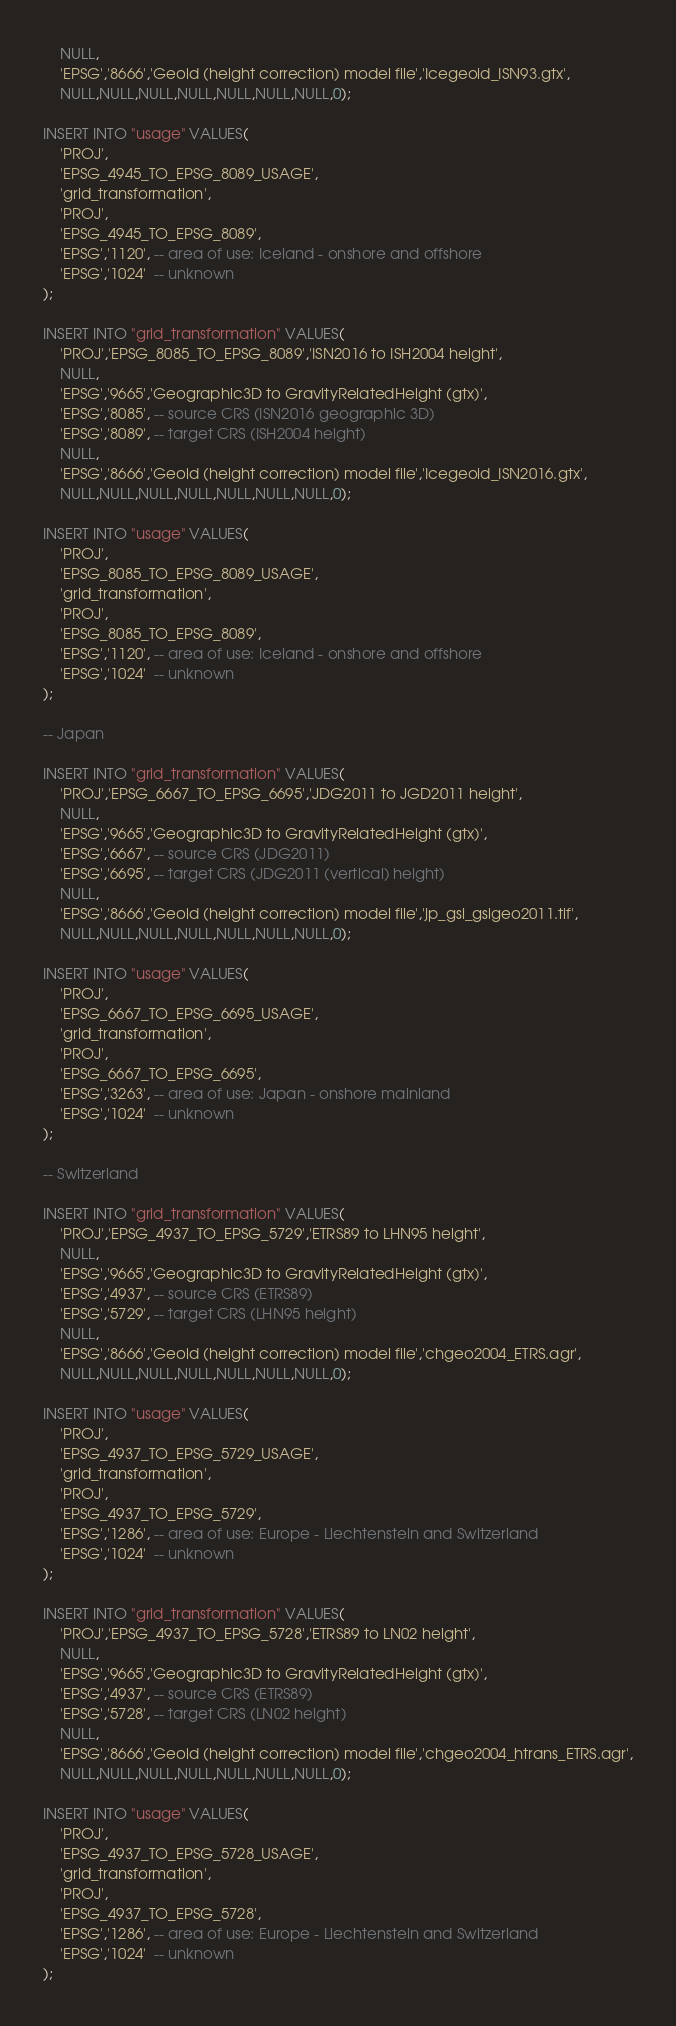<code> <loc_0><loc_0><loc_500><loc_500><_SQL_>    NULL,
    'EPSG','8666','Geoid (height correction) model file','Icegeoid_ISN93.gtx',
    NULL,NULL,NULL,NULL,NULL,NULL,NULL,0);

INSERT INTO "usage" VALUES(
    'PROJ',
    'EPSG_4945_TO_EPSG_8089_USAGE',
    'grid_transformation',
    'PROJ',
    'EPSG_4945_TO_EPSG_8089',
    'EPSG','1120', -- area of use: Iceland - onshore and offshore
    'EPSG','1024'  -- unknown
);

INSERT INTO "grid_transformation" VALUES(
    'PROJ','EPSG_8085_TO_EPSG_8089','ISN2016 to ISH2004 height',
    NULL,
    'EPSG','9665','Geographic3D to GravityRelatedHeight (gtx)',
    'EPSG','8085', -- source CRS (ISN2016 geographic 3D)
    'EPSG','8089', -- target CRS (ISH2004 height)
    NULL,
    'EPSG','8666','Geoid (height correction) model file','Icegeoid_ISN2016.gtx',
    NULL,NULL,NULL,NULL,NULL,NULL,NULL,0);

INSERT INTO "usage" VALUES(
    'PROJ',
    'EPSG_8085_TO_EPSG_8089_USAGE',
    'grid_transformation',
    'PROJ',
    'EPSG_8085_TO_EPSG_8089',
    'EPSG','1120', -- area of use: Iceland - onshore and offshore
    'EPSG','1024'  -- unknown
);

-- Japan

INSERT INTO "grid_transformation" VALUES(
    'PROJ','EPSG_6667_TO_EPSG_6695','JDG2011 to JGD2011 height',
    NULL,
    'EPSG','9665','Geographic3D to GravityRelatedHeight (gtx)',
    'EPSG','6667', -- source CRS (JDG2011)
    'EPSG','6695', -- target CRS (JDG2011 (vertical) height)
    NULL,
    'EPSG','8666','Geoid (height correction) model file','jp_gsi_gsigeo2011.tif',
    NULL,NULL,NULL,NULL,NULL,NULL,NULL,0);

INSERT INTO "usage" VALUES(
    'PROJ',
    'EPSG_6667_TO_EPSG_6695_USAGE',
    'grid_transformation',
    'PROJ',
    'EPSG_6667_TO_EPSG_6695',
    'EPSG','3263', -- area of use: Japan - onshore mainland
    'EPSG','1024'  -- unknown
);

-- Switzerland

INSERT INTO "grid_transformation" VALUES(
    'PROJ','EPSG_4937_TO_EPSG_5729','ETRS89 to LHN95 height',
    NULL,
    'EPSG','9665','Geographic3D to GravityRelatedHeight (gtx)',
    'EPSG','4937', -- source CRS (ETRS89)
    'EPSG','5729', -- target CRS (LHN95 height)
    NULL,
    'EPSG','8666','Geoid (height correction) model file','chgeo2004_ETRS.agr',
    NULL,NULL,NULL,NULL,NULL,NULL,NULL,0);

INSERT INTO "usage" VALUES(
    'PROJ',
    'EPSG_4937_TO_EPSG_5729_USAGE',
    'grid_transformation',
    'PROJ',
    'EPSG_4937_TO_EPSG_5729',
    'EPSG','1286', -- area of use: Europe - Liechtenstein and Switzerland
    'EPSG','1024'  -- unknown
);

INSERT INTO "grid_transformation" VALUES(
    'PROJ','EPSG_4937_TO_EPSG_5728','ETRS89 to LN02 height',
    NULL,
    'EPSG','9665','Geographic3D to GravityRelatedHeight (gtx)',
    'EPSG','4937', -- source CRS (ETRS89)
    'EPSG','5728', -- target CRS (LN02 height)
    NULL,
    'EPSG','8666','Geoid (height correction) model file','chgeo2004_htrans_ETRS.agr',
    NULL,NULL,NULL,NULL,NULL,NULL,NULL,0);

INSERT INTO "usage" VALUES(
    'PROJ',
    'EPSG_4937_TO_EPSG_5728_USAGE',
    'grid_transformation',
    'PROJ',
    'EPSG_4937_TO_EPSG_5728',
    'EPSG','1286', -- area of use: Europe - Liechtenstein and Switzerland
    'EPSG','1024'  -- unknown
);
</code> 